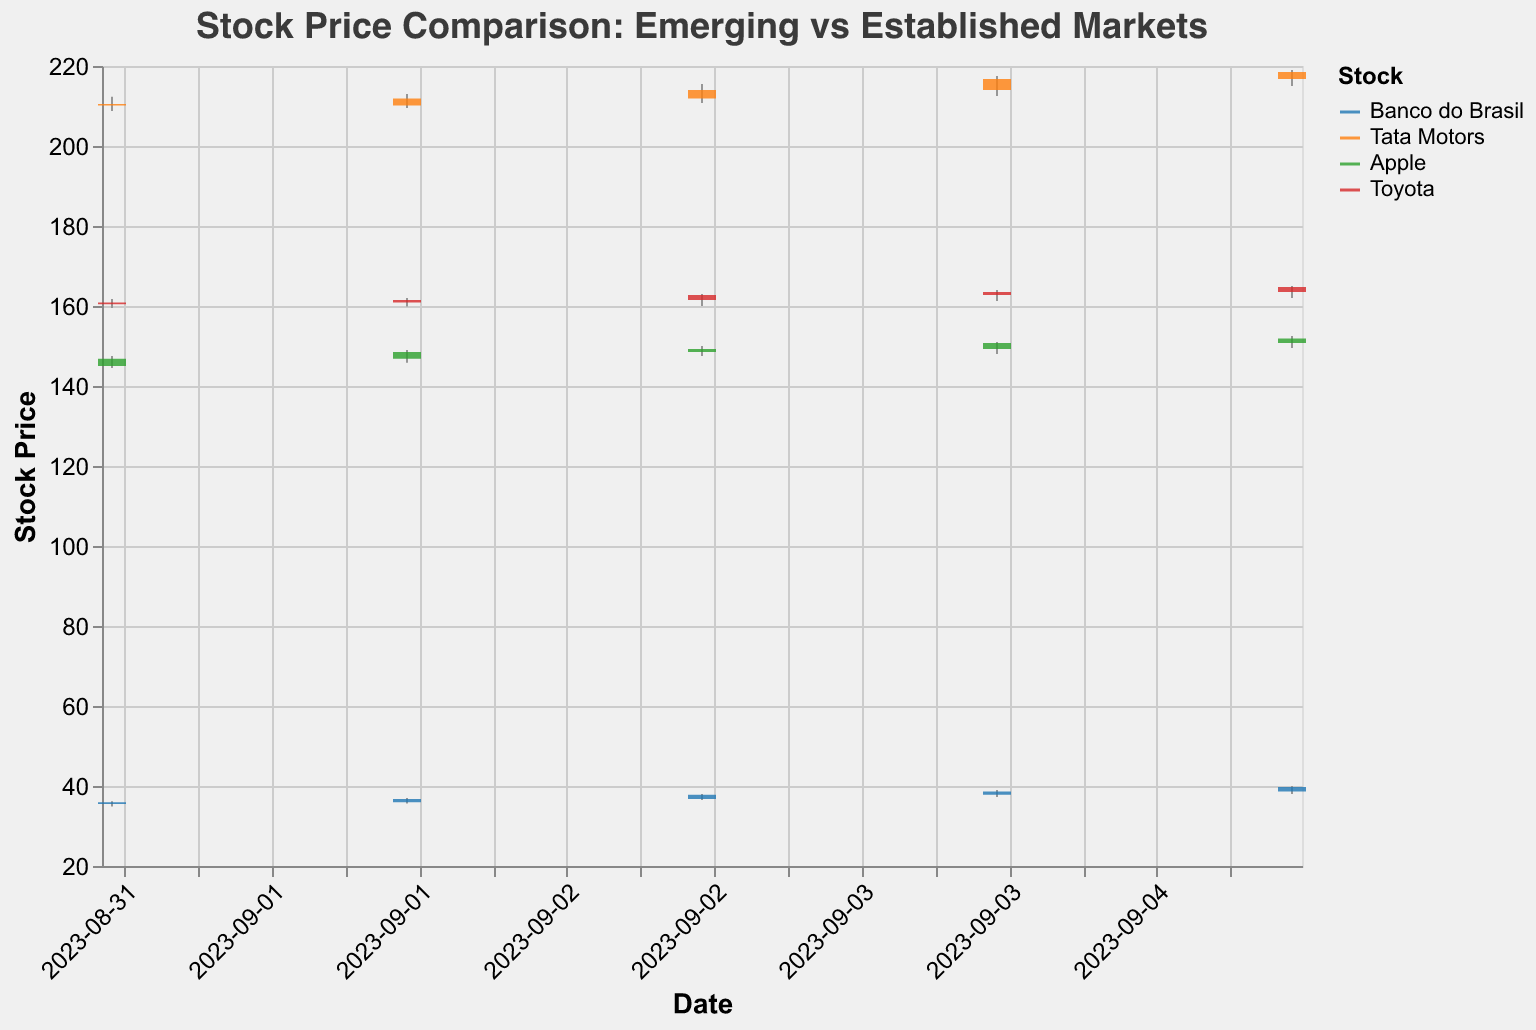What is the title of the figure? The title of the figure is displayed at the top and reads "Stock Price Comparison: Emerging vs Established Markets".
Answer: Stock Price Comparison: Emerging vs Established Markets Which stock has the highest closing price on September 5, 2023? The highest closing price on September 5, 2023, can be found by looking at the "Close" values for that date. Tata Motors has the highest closing price of 218.50.
Answer: Tata Motors How did the closing price of Apple change between September 1 and September 5, 2023? Look at the "Close" values for Apple from September 1 to September 5. The price increased from 146.80 on September 1 to 151.85 on September 5, showing an increase of 5.05.
Answer: Increased by 5.05 Which stock experienced the highest volatility in terms of price range between September 1 and September 5, 2023? Volatility can be determined by the difference between the highest "High" and the lowest "Low" values for each stock over the specified dates. Banco do Brasil has the highest volatility with a range from 40.00 (High on Sep 5) to 34.85 (Low on Sep 1), amounting to 5.15.
Answer: Banco do Brasil What is the trend of closing prices for Toyota from September 1 to September 5, 2023? To determine the trend, check the "Close" values for Toyota across the specified dates. The closing prices show a generally increasing trend: 160.90, 161.50, 162.75, 163.50, 164.75.
Answer: Increasing Generate a chart specific question for candlestick chart type: Over the 5-day period, did Banco do Brasil have more sessions closing above the opening price than Apple? For Banco do Brasil, count the sessions where "Close" > "Open" and compare it to Apple. Banco do Brasil had 4 sessions closing above the opening price (Sep 1, 2, 3, 4, 5) while Apple had 4 as well (Sep 1, 2, 3, 5). Hence, both have the same number.
Answer: No Compare the average closing prices of establishing market stocks (Apple and Toyota) and emerging market stocks (Banco do Brasil and Tata Motors). Which group has a higher average closing price for the period? Calculate the average closing price for established markets (Apple: [146.80, 148.50, 149.25, 150.75, 151.85]; Toyota: [160.90, 161.50, 162.75, 163.50, 164.75]) and emerging markets (Banco do Brasil: [35.95, 36.75, 37.80, 38.60, 39.75]; Tata Motors: [210.15, 211.85, 214.00, 216.75, 218.50]). Established: (146.80+148.50+149.25+150.75+151.85+160.90+161.50+162.75+163.50+164.75)/10 = 150.16; Emerging: (35.95+36.75+37.80+38.60+39.75+210.15+211.85+214.00+216.75+218.50)/10 = 116.41. The established market stocks have a higher average closing price.
Answer: Established market stocks Which stock had the highest single-day price increase in absolute terms and on which date? To find the highest single-day price increase, subtract the "Open" price from the "Close" price for each stock on each date. Tata Motors had the highest single-day increase on September 5, 2023, with (218.50 - 216.75) = 1.75.
Answer: Tata Motors on September 5, 2023 Which stock has the highest trading volume over the 5-day period? Sum up the "Volume" for each stock over the 5 days. Apple has the highest trading volume: 1800000+1900000+2000000+2100000+2200000 = 10000000.
Answer: Apple 